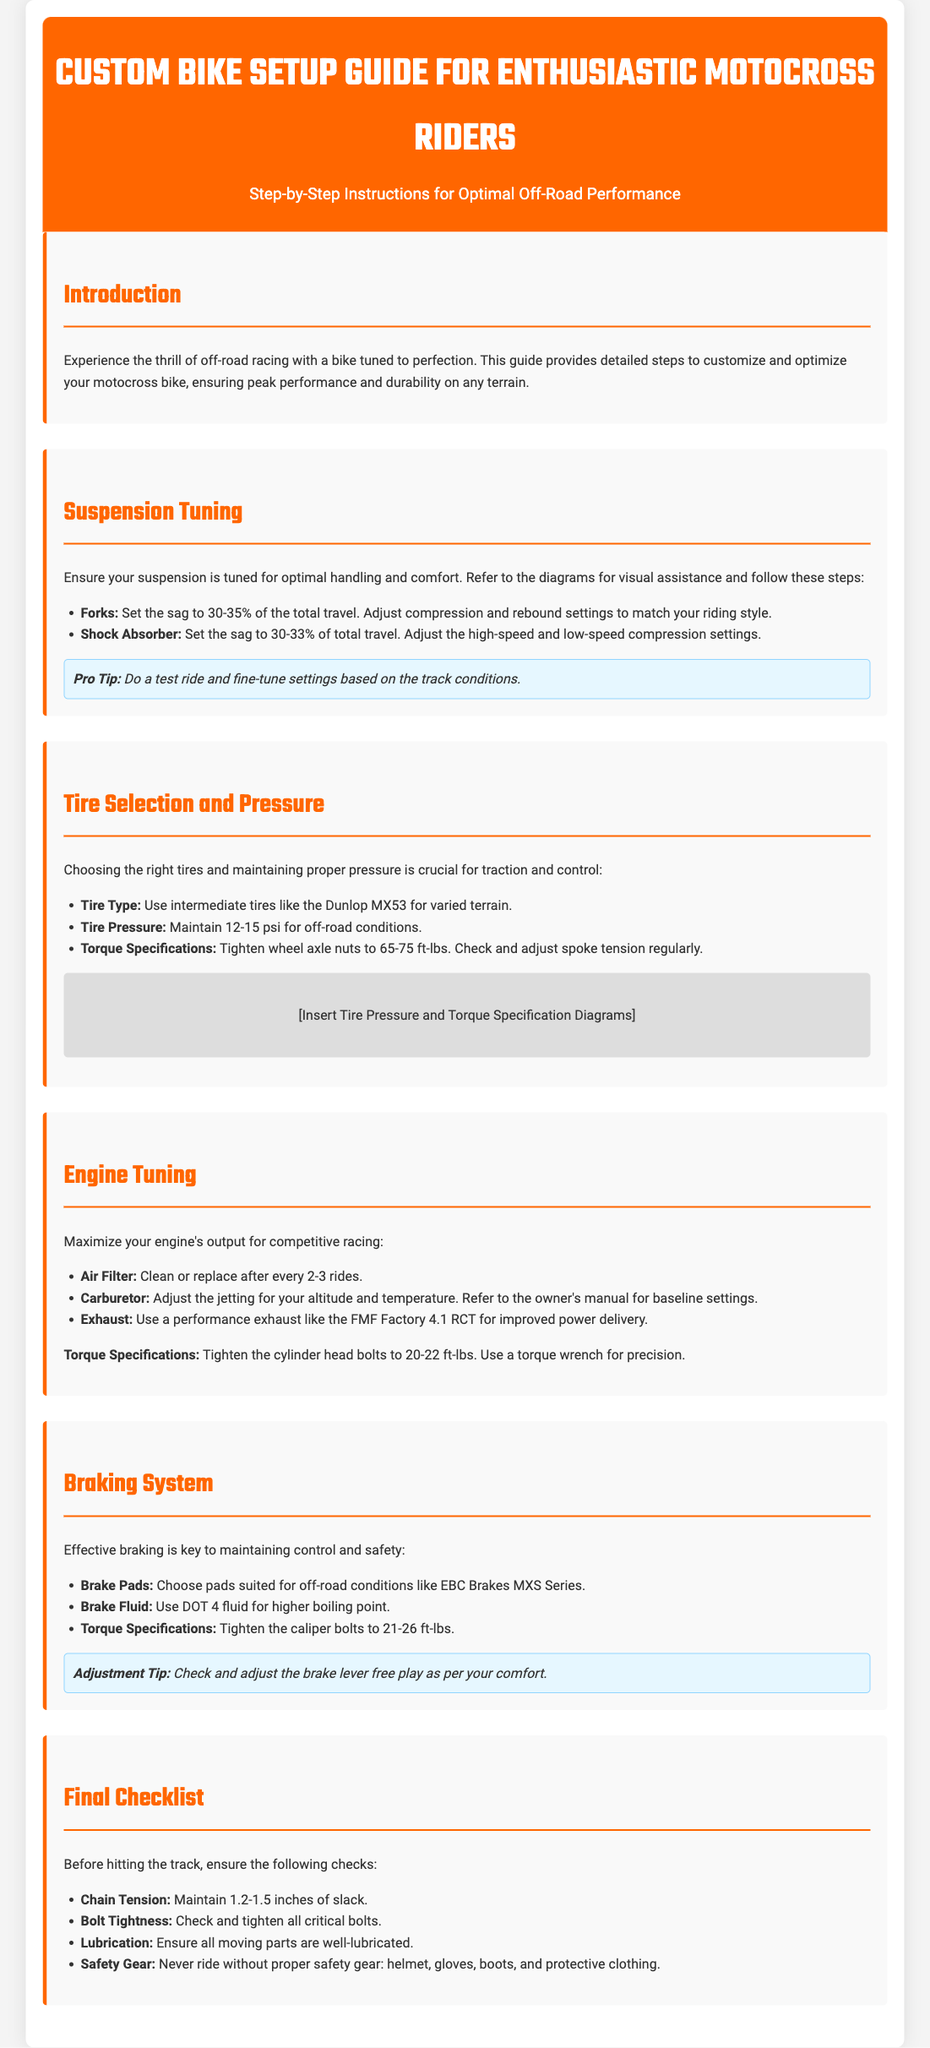What is the target sag percentage for forks? The document specifies that the sag for forks should be set to 30-35% of the total travel.
Answer: 30-35% What type of tire is recommended for varied terrain? The guide recommends using intermediate tires like the Dunlop MX53 for varied terrain.
Answer: Dunlop MX53 What should the tire pressure be for off-road conditions? The document states that the tire pressure should be maintained at 12-15 psi for off-road conditions.
Answer: 12-15 psi What is the torque specification for tightening wheel axle nuts? The torque specification for tightening wheel axle nuts is 65-75 ft-lbs.
Answer: 65-75 ft-lbs How often should the air filter be cleaned or replaced? The document advises cleaning or replacing the air filter after every 2-3 rides.
Answer: 2-3 rides Which brake fluid is recommended in the guide? The guide recommends using DOT 4 fluid for higher boiling point in the braking system.
Answer: DOT 4 What is the suggested slack for chain tension? According to the document, the suggested slack for chain tension is 1.2-1.5 inches.
Answer: 1.2-1.5 inches What component is suggested for improved power delivery? The document suggests using a performance exhaust like the FMF Factory 4.1 RCT for improved power delivery.
Answer: FMF Factory 4.1 RCT 